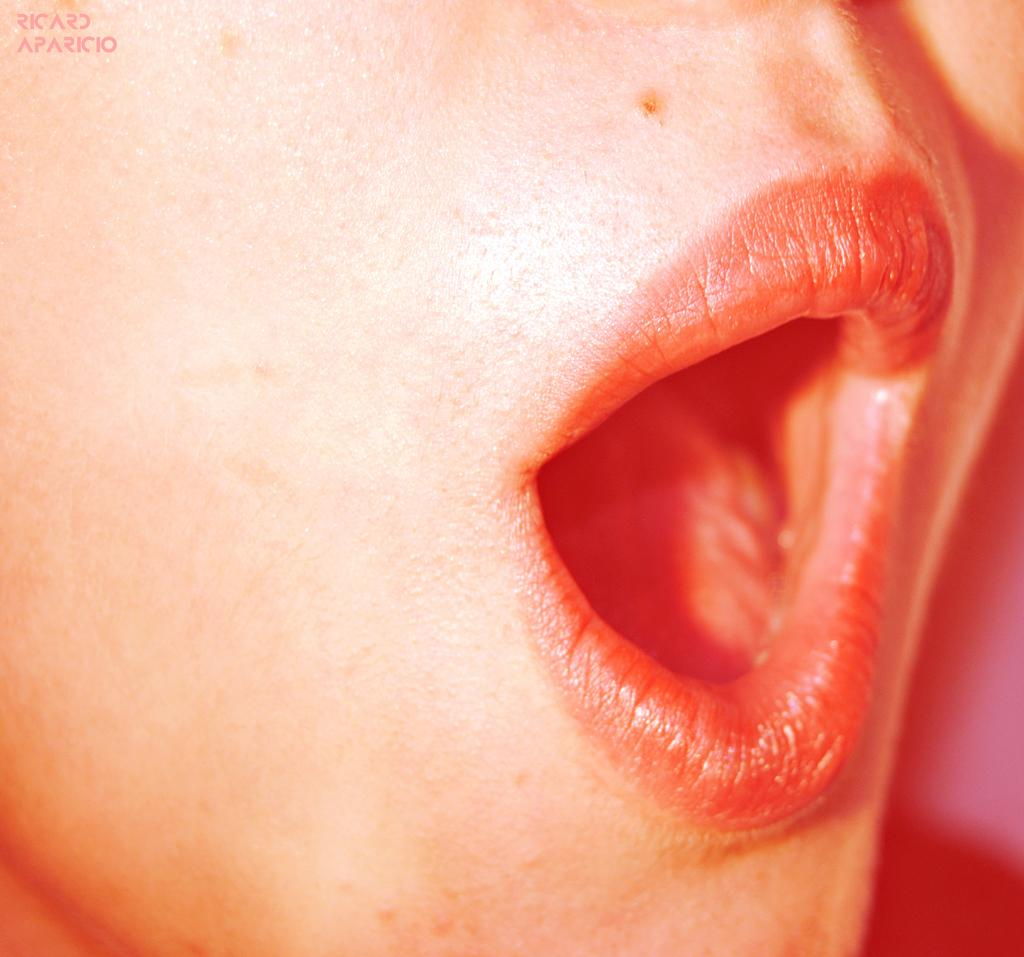What is the main subject of the image? There is a person's face in the image. What facial feature can be seen in the image? There is a mouth in the image. What part of the mouth is visible? There are lips in the image. What is inside the mouth? There is a tongue in the image. What is located towards the top of the image? There is text towards the top of the image. How many fish are swimming in the person's mouth in the image? There are no fish present in the image, as it features a person's face with a mouth, lips, and tongue. What type of parcel can be seen being delivered by a scientist in the image? There is no parcel or scientist present in the image; it only features a person's face with text towards the top. 